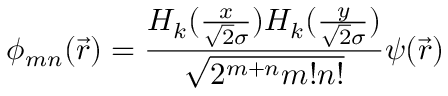<formula> <loc_0><loc_0><loc_500><loc_500>\phi _ { m n } ( \vec { r } ) = \frac { H _ { k } ( \frac { x } { \sqrt { 2 } \sigma } ) H _ { k } ( \frac { y } { \sqrt { 2 } \sigma } ) } { \sqrt { 2 ^ { m + n } m ! n ! } } \psi ( \vec { r } )</formula> 